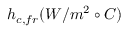<formula> <loc_0><loc_0><loc_500><loc_500>h _ { c , f r } ( W / m ^ { 2 } \circ C )</formula> 